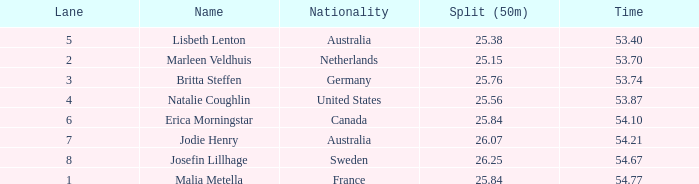What is the overall count of swimming lane(s) for swedish swimmers who have a 50m split quicker than 2 None. 